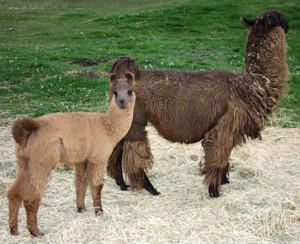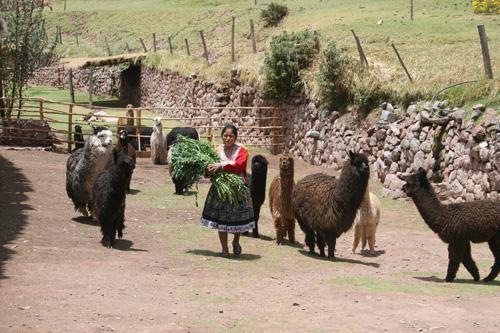The first image is the image on the left, the second image is the image on the right. Evaluate the accuracy of this statement regarding the images: "There are two standing llamas in a field.". Is it true? Answer yes or no. Yes. The first image is the image on the left, the second image is the image on the right. Given the left and right images, does the statement "There are three llamas standing in the left image." hold true? Answer yes or no. No. 